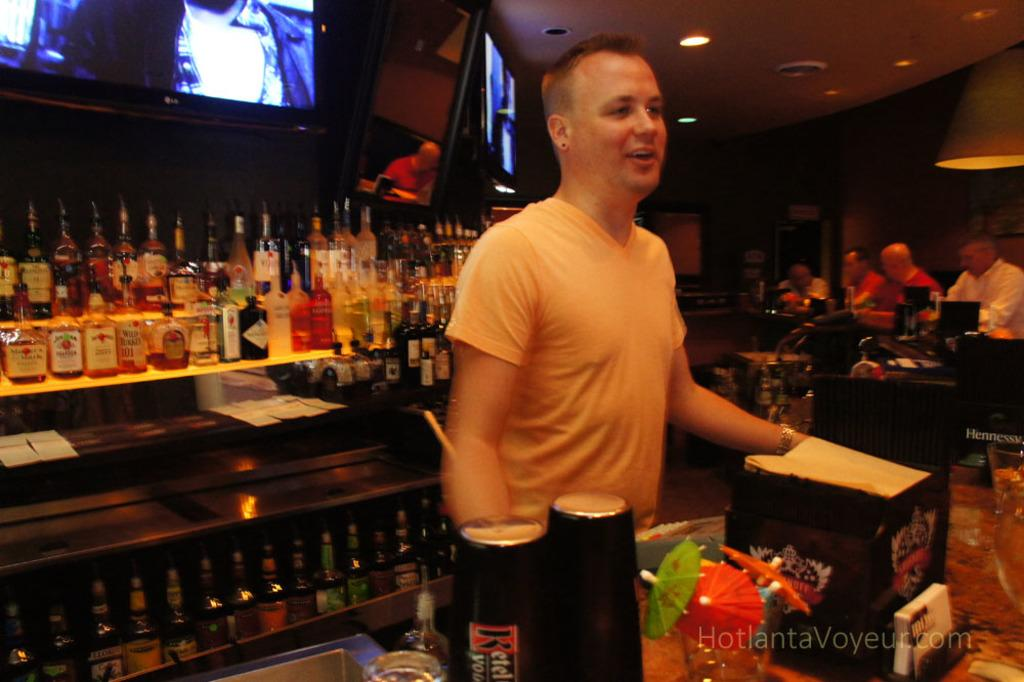<image>
Offer a succinct explanation of the picture presented. The picture of the busy bar is provided by HotlantaVoyeur.com. 